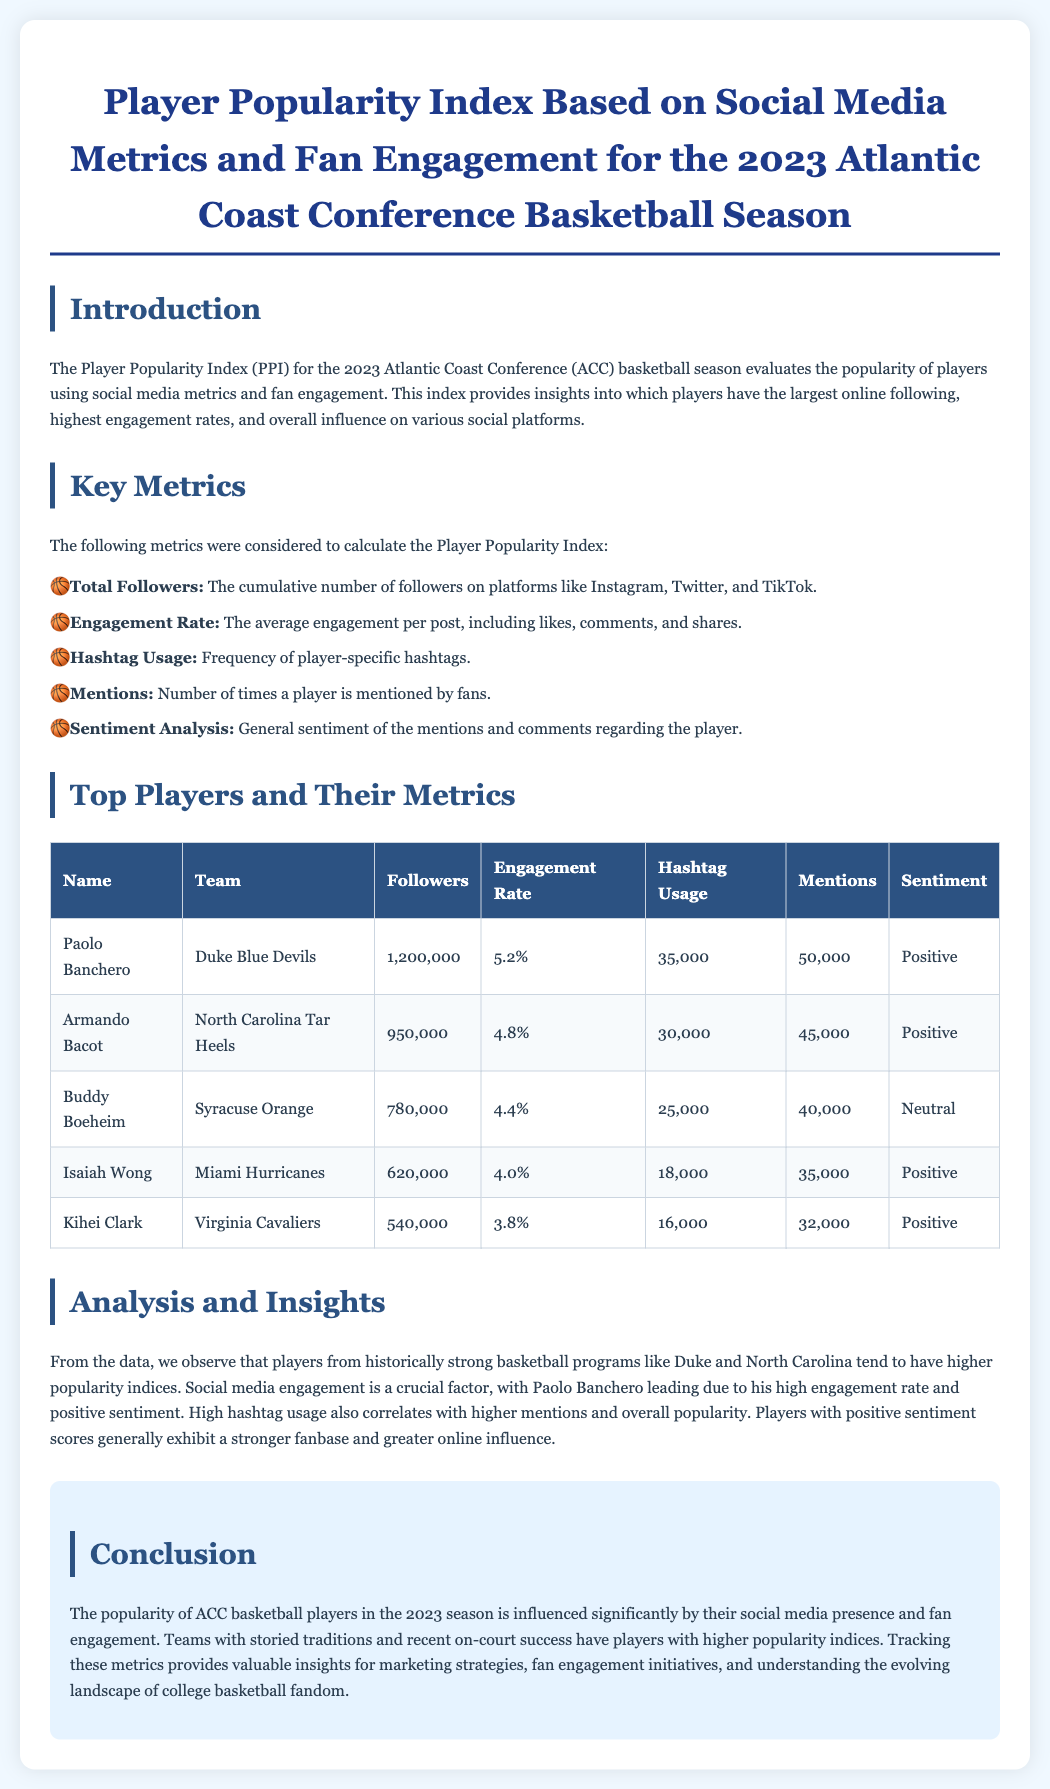What is the Player Popularity Index (PPI)? The PPI evaluates the popularity of players using social media metrics and fan engagement.
Answer: evaluates popularity Who has the highest number of followers? Paolo Banchero has the highest number of followers at 1,200,000.
Answer: Paolo Banchero What is Armando Bacot's engagement rate? His engagement rate is 4.8%, which is listed in the player metrics table.
Answer: 4.8% What team does Isaías Wong play for? The document specifies that he plays for the Miami Hurricanes.
Answer: Miami Hurricanes What sentiment score does Buddy Boeheim have? The sentiment listed for Buddy Boeheim is Neutral.
Answer: Neutral Which player's hashtag usage is 35,000? The document states that Paolo Banchero has a hashtag usage of 35,000.
Answer: Paolo Banchero How many total followers does Kihei Clark have? The document lists Kihei Clark's total followers as 540,000.
Answer: 540,000 Which metrics are considered for calculating the PPI? Total Followers, Engagement Rate, Hashtag Usage, Mentions, and Sentiment Analysis are considered.
Answer: Total Followers, Engagement Rate, Hashtag Usage, Mentions, Sentiment Analysis What does a positive sentiment indicate according to the document? Positive sentiment indicates a stronger fanbase and greater online influence.
Answer: stronger fanbase 